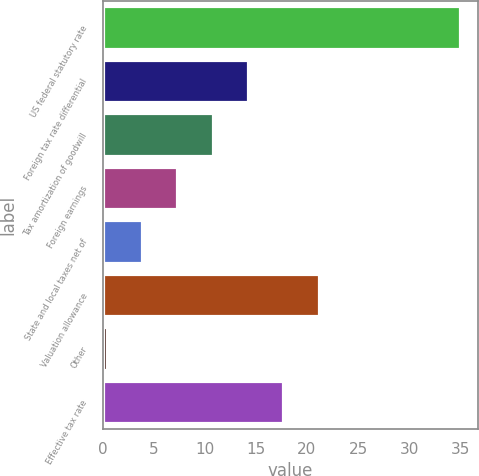Convert chart. <chart><loc_0><loc_0><loc_500><loc_500><bar_chart><fcel>US federal statutory rate<fcel>Foreign tax rate differential<fcel>Tax amortization of goodwill<fcel>Foreign earnings<fcel>State and local taxes net of<fcel>Valuation allowance<fcel>Other<fcel>Effective tax rate<nl><fcel>35<fcel>14.24<fcel>10.78<fcel>7.32<fcel>3.86<fcel>21.16<fcel>0.4<fcel>17.7<nl></chart> 